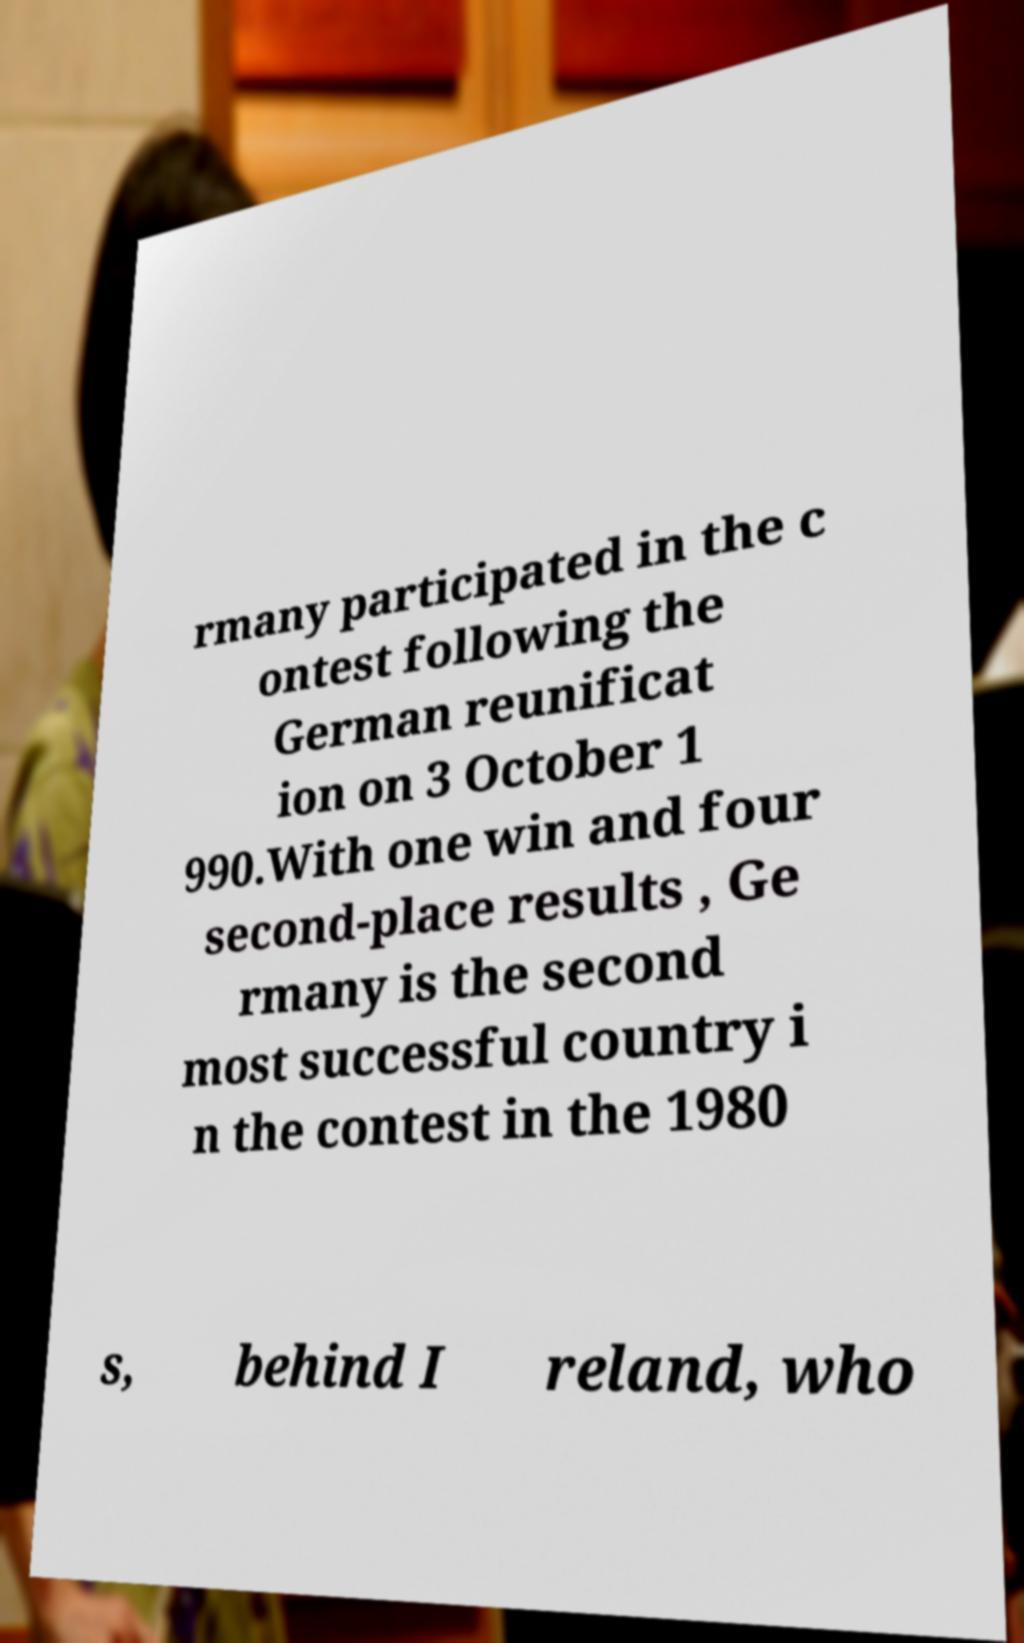Could you assist in decoding the text presented in this image and type it out clearly? rmany participated in the c ontest following the German reunificat ion on 3 October 1 990.With one win and four second-place results , Ge rmany is the second most successful country i n the contest in the 1980 s, behind I reland, who 